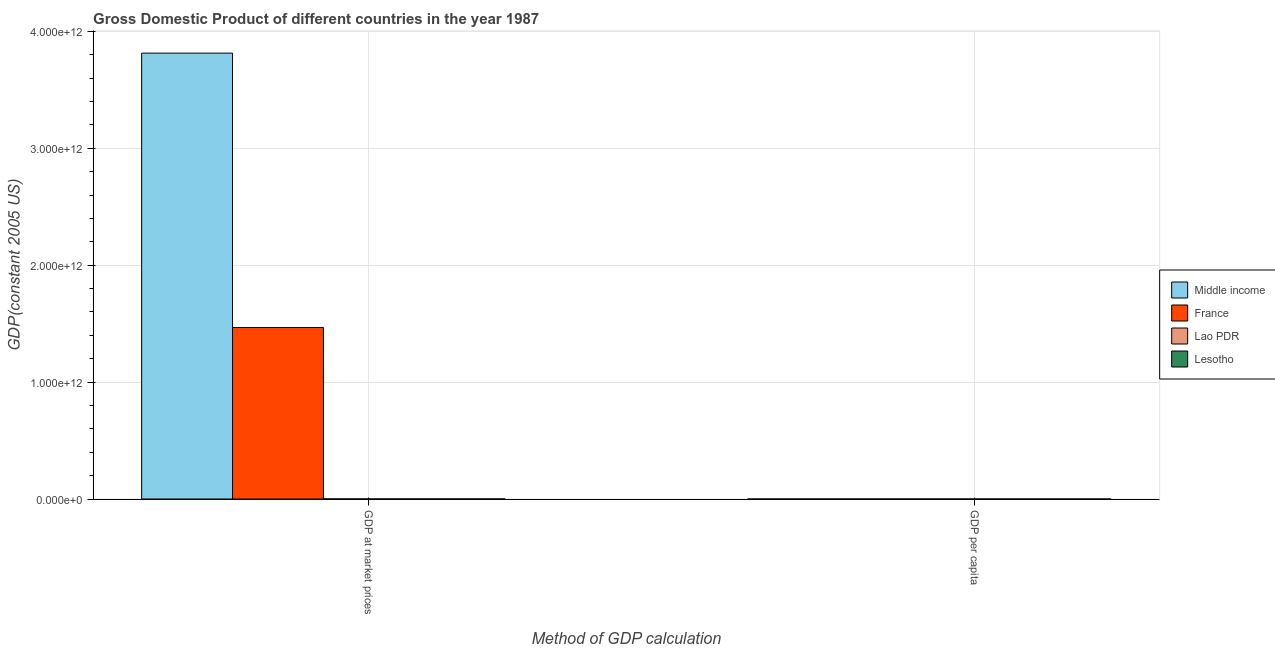How many groups of bars are there?
Give a very brief answer. 2. Are the number of bars per tick equal to the number of legend labels?
Make the answer very short. Yes. How many bars are there on the 1st tick from the left?
Your answer should be very brief. 4. How many bars are there on the 2nd tick from the right?
Provide a succinct answer. 4. What is the label of the 1st group of bars from the left?
Offer a terse response. GDP at market prices. What is the gdp per capita in France?
Offer a very short reply. 2.55e+04. Across all countries, what is the maximum gdp per capita?
Your answer should be very brief. 2.55e+04. Across all countries, what is the minimum gdp per capita?
Ensure brevity in your answer.  238.7. In which country was the gdp per capita maximum?
Offer a terse response. France. In which country was the gdp per capita minimum?
Provide a succinct answer. Lao PDR. What is the total gdp per capita in the graph?
Offer a very short reply. 2.73e+04. What is the difference between the gdp per capita in Lesotho and that in Lao PDR?
Offer a very short reply. 204.92. What is the difference between the gdp per capita in Middle income and the gdp at market prices in Lesotho?
Make the answer very short. -6.74e+08. What is the average gdp per capita per country?
Make the answer very short. 6820.13. What is the difference between the gdp per capita and gdp at market prices in Lao PDR?
Your answer should be very brief. -9.30e+08. In how many countries, is the gdp per capita greater than 200000000000 US$?
Ensure brevity in your answer.  0. What is the ratio of the gdp per capita in France to that in Middle income?
Offer a very short reply. 23.69. What does the 2nd bar from the right in GDP at market prices represents?
Your answer should be very brief. Lao PDR. How many bars are there?
Your answer should be compact. 8. How many countries are there in the graph?
Ensure brevity in your answer.  4. What is the difference between two consecutive major ticks on the Y-axis?
Offer a terse response. 1.00e+12. Are the values on the major ticks of Y-axis written in scientific E-notation?
Ensure brevity in your answer.  Yes. Does the graph contain grids?
Your answer should be very brief. Yes. How are the legend labels stacked?
Your answer should be very brief. Vertical. What is the title of the graph?
Provide a short and direct response. Gross Domestic Product of different countries in the year 1987. Does "Costa Rica" appear as one of the legend labels in the graph?
Keep it short and to the point. No. What is the label or title of the X-axis?
Ensure brevity in your answer.  Method of GDP calculation. What is the label or title of the Y-axis?
Your answer should be very brief. GDP(constant 2005 US). What is the GDP(constant 2005 US) of Middle income in GDP at market prices?
Your answer should be compact. 3.81e+12. What is the GDP(constant 2005 US) of France in GDP at market prices?
Provide a short and direct response. 1.47e+12. What is the GDP(constant 2005 US) in Lao PDR in GDP at market prices?
Provide a short and direct response. 9.30e+08. What is the GDP(constant 2005 US) in Lesotho in GDP at market prices?
Give a very brief answer. 6.74e+08. What is the GDP(constant 2005 US) of Middle income in GDP per capita?
Your answer should be compact. 1077.13. What is the GDP(constant 2005 US) in France in GDP per capita?
Provide a short and direct response. 2.55e+04. What is the GDP(constant 2005 US) in Lao PDR in GDP per capita?
Provide a succinct answer. 238.7. What is the GDP(constant 2005 US) in Lesotho in GDP per capita?
Your answer should be very brief. 443.63. Across all Method of GDP calculation, what is the maximum GDP(constant 2005 US) of Middle income?
Provide a short and direct response. 3.81e+12. Across all Method of GDP calculation, what is the maximum GDP(constant 2005 US) in France?
Offer a terse response. 1.47e+12. Across all Method of GDP calculation, what is the maximum GDP(constant 2005 US) in Lao PDR?
Your response must be concise. 9.30e+08. Across all Method of GDP calculation, what is the maximum GDP(constant 2005 US) in Lesotho?
Offer a terse response. 6.74e+08. Across all Method of GDP calculation, what is the minimum GDP(constant 2005 US) in Middle income?
Give a very brief answer. 1077.13. Across all Method of GDP calculation, what is the minimum GDP(constant 2005 US) in France?
Ensure brevity in your answer.  2.55e+04. Across all Method of GDP calculation, what is the minimum GDP(constant 2005 US) of Lao PDR?
Provide a short and direct response. 238.7. Across all Method of GDP calculation, what is the minimum GDP(constant 2005 US) of Lesotho?
Keep it short and to the point. 443.63. What is the total GDP(constant 2005 US) in Middle income in the graph?
Provide a short and direct response. 3.81e+12. What is the total GDP(constant 2005 US) of France in the graph?
Make the answer very short. 1.47e+12. What is the total GDP(constant 2005 US) of Lao PDR in the graph?
Your answer should be compact. 9.30e+08. What is the total GDP(constant 2005 US) in Lesotho in the graph?
Offer a terse response. 6.74e+08. What is the difference between the GDP(constant 2005 US) in Middle income in GDP at market prices and that in GDP per capita?
Your answer should be compact. 3.81e+12. What is the difference between the GDP(constant 2005 US) of France in GDP at market prices and that in GDP per capita?
Provide a succinct answer. 1.47e+12. What is the difference between the GDP(constant 2005 US) of Lao PDR in GDP at market prices and that in GDP per capita?
Provide a short and direct response. 9.30e+08. What is the difference between the GDP(constant 2005 US) in Lesotho in GDP at market prices and that in GDP per capita?
Keep it short and to the point. 6.74e+08. What is the difference between the GDP(constant 2005 US) of Middle income in GDP at market prices and the GDP(constant 2005 US) of France in GDP per capita?
Provide a short and direct response. 3.81e+12. What is the difference between the GDP(constant 2005 US) in Middle income in GDP at market prices and the GDP(constant 2005 US) in Lao PDR in GDP per capita?
Ensure brevity in your answer.  3.81e+12. What is the difference between the GDP(constant 2005 US) in Middle income in GDP at market prices and the GDP(constant 2005 US) in Lesotho in GDP per capita?
Keep it short and to the point. 3.81e+12. What is the difference between the GDP(constant 2005 US) in France in GDP at market prices and the GDP(constant 2005 US) in Lao PDR in GDP per capita?
Make the answer very short. 1.47e+12. What is the difference between the GDP(constant 2005 US) of France in GDP at market prices and the GDP(constant 2005 US) of Lesotho in GDP per capita?
Offer a terse response. 1.47e+12. What is the difference between the GDP(constant 2005 US) in Lao PDR in GDP at market prices and the GDP(constant 2005 US) in Lesotho in GDP per capita?
Offer a very short reply. 9.30e+08. What is the average GDP(constant 2005 US) in Middle income per Method of GDP calculation?
Provide a short and direct response. 1.91e+12. What is the average GDP(constant 2005 US) of France per Method of GDP calculation?
Keep it short and to the point. 7.34e+11. What is the average GDP(constant 2005 US) in Lao PDR per Method of GDP calculation?
Provide a succinct answer. 4.65e+08. What is the average GDP(constant 2005 US) in Lesotho per Method of GDP calculation?
Offer a very short reply. 3.37e+08. What is the difference between the GDP(constant 2005 US) of Middle income and GDP(constant 2005 US) of France in GDP at market prices?
Offer a very short reply. 2.35e+12. What is the difference between the GDP(constant 2005 US) of Middle income and GDP(constant 2005 US) of Lao PDR in GDP at market prices?
Your answer should be very brief. 3.81e+12. What is the difference between the GDP(constant 2005 US) of Middle income and GDP(constant 2005 US) of Lesotho in GDP at market prices?
Your answer should be very brief. 3.81e+12. What is the difference between the GDP(constant 2005 US) in France and GDP(constant 2005 US) in Lao PDR in GDP at market prices?
Your answer should be very brief. 1.47e+12. What is the difference between the GDP(constant 2005 US) of France and GDP(constant 2005 US) of Lesotho in GDP at market prices?
Offer a terse response. 1.47e+12. What is the difference between the GDP(constant 2005 US) in Lao PDR and GDP(constant 2005 US) in Lesotho in GDP at market prices?
Keep it short and to the point. 2.55e+08. What is the difference between the GDP(constant 2005 US) in Middle income and GDP(constant 2005 US) in France in GDP per capita?
Offer a terse response. -2.44e+04. What is the difference between the GDP(constant 2005 US) in Middle income and GDP(constant 2005 US) in Lao PDR in GDP per capita?
Make the answer very short. 838.43. What is the difference between the GDP(constant 2005 US) in Middle income and GDP(constant 2005 US) in Lesotho in GDP per capita?
Your response must be concise. 633.51. What is the difference between the GDP(constant 2005 US) in France and GDP(constant 2005 US) in Lao PDR in GDP per capita?
Give a very brief answer. 2.53e+04. What is the difference between the GDP(constant 2005 US) in France and GDP(constant 2005 US) in Lesotho in GDP per capita?
Provide a succinct answer. 2.51e+04. What is the difference between the GDP(constant 2005 US) of Lao PDR and GDP(constant 2005 US) of Lesotho in GDP per capita?
Offer a terse response. -204.92. What is the ratio of the GDP(constant 2005 US) of Middle income in GDP at market prices to that in GDP per capita?
Provide a succinct answer. 3.54e+09. What is the ratio of the GDP(constant 2005 US) of France in GDP at market prices to that in GDP per capita?
Offer a terse response. 5.75e+07. What is the ratio of the GDP(constant 2005 US) in Lao PDR in GDP at market prices to that in GDP per capita?
Your answer should be very brief. 3.90e+06. What is the ratio of the GDP(constant 2005 US) in Lesotho in GDP at market prices to that in GDP per capita?
Ensure brevity in your answer.  1.52e+06. What is the difference between the highest and the second highest GDP(constant 2005 US) of Middle income?
Ensure brevity in your answer.  3.81e+12. What is the difference between the highest and the second highest GDP(constant 2005 US) in France?
Ensure brevity in your answer.  1.47e+12. What is the difference between the highest and the second highest GDP(constant 2005 US) of Lao PDR?
Your response must be concise. 9.30e+08. What is the difference between the highest and the second highest GDP(constant 2005 US) in Lesotho?
Keep it short and to the point. 6.74e+08. What is the difference between the highest and the lowest GDP(constant 2005 US) in Middle income?
Provide a short and direct response. 3.81e+12. What is the difference between the highest and the lowest GDP(constant 2005 US) in France?
Offer a terse response. 1.47e+12. What is the difference between the highest and the lowest GDP(constant 2005 US) in Lao PDR?
Offer a terse response. 9.30e+08. What is the difference between the highest and the lowest GDP(constant 2005 US) in Lesotho?
Your answer should be very brief. 6.74e+08. 